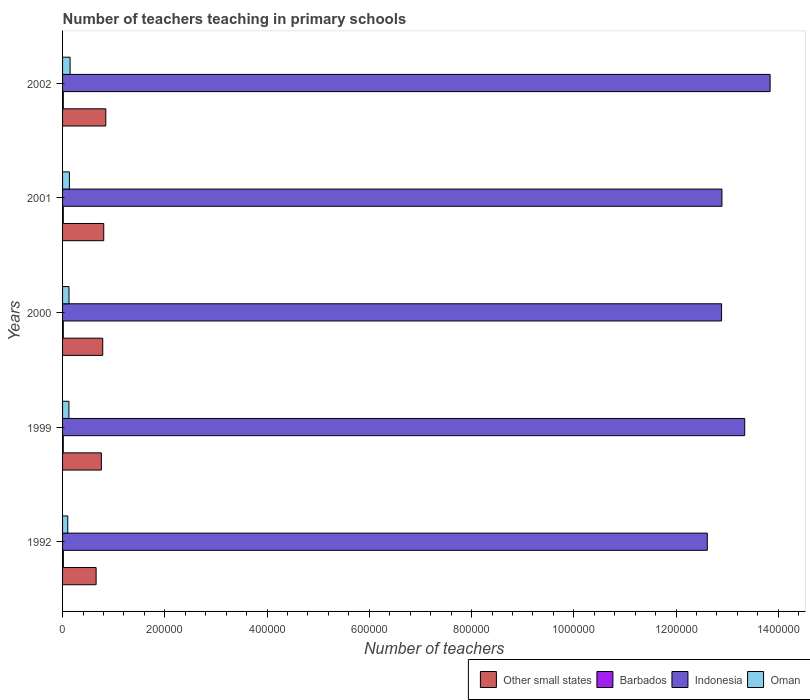How many different coloured bars are there?
Provide a succinct answer. 4. How many groups of bars are there?
Keep it short and to the point. 5. How many bars are there on the 1st tick from the bottom?
Offer a very short reply. 4. What is the label of the 1st group of bars from the top?
Give a very brief answer. 2002. What is the number of teachers teaching in primary schools in Barbados in 1992?
Offer a very short reply. 1553. Across all years, what is the maximum number of teachers teaching in primary schools in Barbados?
Provide a succinct answer. 1553. Across all years, what is the minimum number of teachers teaching in primary schools in Other small states?
Provide a short and direct response. 6.56e+04. In which year was the number of teachers teaching in primary schools in Oman minimum?
Ensure brevity in your answer.  1992. What is the total number of teachers teaching in primary schools in Oman in the graph?
Provide a short and direct response. 6.33e+04. What is the difference between the number of teachers teaching in primary schools in Other small states in 1992 and that in 2002?
Your response must be concise. -1.89e+04. What is the difference between the number of teachers teaching in primary schools in Barbados in 2001 and the number of teachers teaching in primary schools in Other small states in 1999?
Provide a succinct answer. -7.45e+04. What is the average number of teachers teaching in primary schools in Barbados per year?
Offer a terse response. 1446.8. In the year 1992, what is the difference between the number of teachers teaching in primary schools in Oman and number of teachers teaching in primary schools in Barbados?
Offer a terse response. 8631. What is the ratio of the number of teachers teaching in primary schools in Other small states in 1999 to that in 2000?
Ensure brevity in your answer.  0.97. Is the number of teachers teaching in primary schools in Other small states in 1999 less than that in 2001?
Provide a succinct answer. Yes. Is the difference between the number of teachers teaching in primary schools in Oman in 2001 and 2002 greater than the difference between the number of teachers teaching in primary schools in Barbados in 2001 and 2002?
Give a very brief answer. No. What is the difference between the highest and the second highest number of teachers teaching in primary schools in Other small states?
Offer a very short reply. 3984.84. What is the difference between the highest and the lowest number of teachers teaching in primary schools in Barbados?
Your answer should be compact. 160. Is it the case that in every year, the sum of the number of teachers teaching in primary schools in Other small states and number of teachers teaching in primary schools in Oman is greater than the sum of number of teachers teaching in primary schools in Indonesia and number of teachers teaching in primary schools in Barbados?
Your response must be concise. Yes. What does the 3rd bar from the top in 2002 represents?
Make the answer very short. Barbados. What does the 1st bar from the bottom in 1999 represents?
Your answer should be very brief. Other small states. Are all the bars in the graph horizontal?
Give a very brief answer. Yes. What is the difference between two consecutive major ticks on the X-axis?
Your response must be concise. 2.00e+05. Are the values on the major ticks of X-axis written in scientific E-notation?
Your answer should be very brief. No. Does the graph contain grids?
Make the answer very short. No. Where does the legend appear in the graph?
Offer a very short reply. Bottom right. How many legend labels are there?
Offer a very short reply. 4. How are the legend labels stacked?
Give a very brief answer. Horizontal. What is the title of the graph?
Provide a short and direct response. Number of teachers teaching in primary schools. Does "Pacific island small states" appear as one of the legend labels in the graph?
Make the answer very short. No. What is the label or title of the X-axis?
Your answer should be compact. Number of teachers. What is the Number of teachers in Other small states in 1992?
Ensure brevity in your answer.  6.56e+04. What is the Number of teachers in Barbados in 1992?
Ensure brevity in your answer.  1553. What is the Number of teachers in Indonesia in 1992?
Ensure brevity in your answer.  1.26e+06. What is the Number of teachers of Oman in 1992?
Make the answer very short. 1.02e+04. What is the Number of teachers in Other small states in 1999?
Offer a very short reply. 7.59e+04. What is the Number of teachers in Barbados in 1999?
Offer a terse response. 1395. What is the Number of teachers of Indonesia in 1999?
Make the answer very short. 1.33e+06. What is the Number of teachers of Oman in 1999?
Provide a short and direct response. 1.24e+04. What is the Number of teachers in Other small states in 2000?
Your answer should be compact. 7.86e+04. What is the Number of teachers of Barbados in 2000?
Offer a terse response. 1393. What is the Number of teachers in Indonesia in 2000?
Provide a short and direct response. 1.29e+06. What is the Number of teachers in Oman in 2000?
Keep it short and to the point. 1.26e+04. What is the Number of teachers in Other small states in 2001?
Offer a very short reply. 8.06e+04. What is the Number of teachers of Barbados in 2001?
Provide a short and direct response. 1422. What is the Number of teachers of Indonesia in 2001?
Offer a terse response. 1.29e+06. What is the Number of teachers in Oman in 2001?
Provide a succinct answer. 1.34e+04. What is the Number of teachers of Other small states in 2002?
Give a very brief answer. 8.45e+04. What is the Number of teachers of Barbados in 2002?
Provide a short and direct response. 1471. What is the Number of teachers of Indonesia in 2002?
Your response must be concise. 1.38e+06. What is the Number of teachers of Oman in 2002?
Your answer should be compact. 1.47e+04. Across all years, what is the maximum Number of teachers of Other small states?
Offer a very short reply. 8.45e+04. Across all years, what is the maximum Number of teachers in Barbados?
Keep it short and to the point. 1553. Across all years, what is the maximum Number of teachers of Indonesia?
Offer a terse response. 1.38e+06. Across all years, what is the maximum Number of teachers of Oman?
Provide a succinct answer. 1.47e+04. Across all years, what is the minimum Number of teachers of Other small states?
Offer a very short reply. 6.56e+04. Across all years, what is the minimum Number of teachers of Barbados?
Give a very brief answer. 1393. Across all years, what is the minimum Number of teachers in Indonesia?
Your response must be concise. 1.26e+06. Across all years, what is the minimum Number of teachers in Oman?
Offer a very short reply. 1.02e+04. What is the total Number of teachers of Other small states in the graph?
Your response must be concise. 3.85e+05. What is the total Number of teachers in Barbados in the graph?
Your answer should be compact. 7234. What is the total Number of teachers of Indonesia in the graph?
Offer a terse response. 6.56e+06. What is the total Number of teachers of Oman in the graph?
Give a very brief answer. 6.33e+04. What is the difference between the Number of teachers of Other small states in 1992 and that in 1999?
Make the answer very short. -1.03e+04. What is the difference between the Number of teachers of Barbados in 1992 and that in 1999?
Ensure brevity in your answer.  158. What is the difference between the Number of teachers in Indonesia in 1992 and that in 1999?
Provide a short and direct response. -7.31e+04. What is the difference between the Number of teachers of Oman in 1992 and that in 1999?
Your answer should be very brief. -2237. What is the difference between the Number of teachers in Other small states in 1992 and that in 2000?
Your answer should be very brief. -1.30e+04. What is the difference between the Number of teachers of Barbados in 1992 and that in 2000?
Ensure brevity in your answer.  160. What is the difference between the Number of teachers of Indonesia in 1992 and that in 2000?
Make the answer very short. -2.79e+04. What is the difference between the Number of teachers of Oman in 1992 and that in 2000?
Your answer should be very brief. -2414. What is the difference between the Number of teachers of Other small states in 1992 and that in 2001?
Your response must be concise. -1.50e+04. What is the difference between the Number of teachers of Barbados in 1992 and that in 2001?
Your answer should be very brief. 131. What is the difference between the Number of teachers of Indonesia in 1992 and that in 2001?
Provide a short and direct response. -2.86e+04. What is the difference between the Number of teachers in Oman in 1992 and that in 2001?
Provide a succinct answer. -3210. What is the difference between the Number of teachers in Other small states in 1992 and that in 2002?
Provide a succinct answer. -1.89e+04. What is the difference between the Number of teachers of Indonesia in 1992 and that in 2002?
Ensure brevity in your answer.  -1.23e+05. What is the difference between the Number of teachers in Oman in 1992 and that in 2002?
Offer a very short reply. -4544. What is the difference between the Number of teachers in Other small states in 1999 and that in 2000?
Ensure brevity in your answer.  -2707.27. What is the difference between the Number of teachers of Barbados in 1999 and that in 2000?
Offer a very short reply. 2. What is the difference between the Number of teachers of Indonesia in 1999 and that in 2000?
Provide a short and direct response. 4.52e+04. What is the difference between the Number of teachers of Oman in 1999 and that in 2000?
Keep it short and to the point. -177. What is the difference between the Number of teachers of Other small states in 1999 and that in 2001?
Offer a terse response. -4683.12. What is the difference between the Number of teachers of Barbados in 1999 and that in 2001?
Ensure brevity in your answer.  -27. What is the difference between the Number of teachers of Indonesia in 1999 and that in 2001?
Give a very brief answer. 4.45e+04. What is the difference between the Number of teachers of Oman in 1999 and that in 2001?
Your answer should be compact. -973. What is the difference between the Number of teachers of Other small states in 1999 and that in 2002?
Your response must be concise. -8667.97. What is the difference between the Number of teachers in Barbados in 1999 and that in 2002?
Provide a short and direct response. -76. What is the difference between the Number of teachers in Indonesia in 1999 and that in 2002?
Keep it short and to the point. -4.97e+04. What is the difference between the Number of teachers of Oman in 1999 and that in 2002?
Give a very brief answer. -2307. What is the difference between the Number of teachers of Other small states in 2000 and that in 2001?
Your response must be concise. -1975.86. What is the difference between the Number of teachers in Indonesia in 2000 and that in 2001?
Keep it short and to the point. -755. What is the difference between the Number of teachers in Oman in 2000 and that in 2001?
Your answer should be very brief. -796. What is the difference between the Number of teachers of Other small states in 2000 and that in 2002?
Your response must be concise. -5960.7. What is the difference between the Number of teachers of Barbados in 2000 and that in 2002?
Make the answer very short. -78. What is the difference between the Number of teachers of Indonesia in 2000 and that in 2002?
Provide a short and direct response. -9.49e+04. What is the difference between the Number of teachers of Oman in 2000 and that in 2002?
Offer a terse response. -2130. What is the difference between the Number of teachers in Other small states in 2001 and that in 2002?
Offer a very short reply. -3984.84. What is the difference between the Number of teachers in Barbados in 2001 and that in 2002?
Your response must be concise. -49. What is the difference between the Number of teachers in Indonesia in 2001 and that in 2002?
Your answer should be compact. -9.42e+04. What is the difference between the Number of teachers in Oman in 2001 and that in 2002?
Ensure brevity in your answer.  -1334. What is the difference between the Number of teachers of Other small states in 1992 and the Number of teachers of Barbados in 1999?
Your response must be concise. 6.42e+04. What is the difference between the Number of teachers of Other small states in 1992 and the Number of teachers of Indonesia in 1999?
Keep it short and to the point. -1.27e+06. What is the difference between the Number of teachers in Other small states in 1992 and the Number of teachers in Oman in 1999?
Provide a short and direct response. 5.32e+04. What is the difference between the Number of teachers of Barbados in 1992 and the Number of teachers of Indonesia in 1999?
Keep it short and to the point. -1.33e+06. What is the difference between the Number of teachers in Barbados in 1992 and the Number of teachers in Oman in 1999?
Keep it short and to the point. -1.09e+04. What is the difference between the Number of teachers of Indonesia in 1992 and the Number of teachers of Oman in 1999?
Make the answer very short. 1.25e+06. What is the difference between the Number of teachers of Other small states in 1992 and the Number of teachers of Barbados in 2000?
Offer a very short reply. 6.42e+04. What is the difference between the Number of teachers of Other small states in 1992 and the Number of teachers of Indonesia in 2000?
Offer a terse response. -1.22e+06. What is the difference between the Number of teachers in Other small states in 1992 and the Number of teachers in Oman in 2000?
Keep it short and to the point. 5.30e+04. What is the difference between the Number of teachers of Barbados in 1992 and the Number of teachers of Indonesia in 2000?
Keep it short and to the point. -1.29e+06. What is the difference between the Number of teachers of Barbados in 1992 and the Number of teachers of Oman in 2000?
Keep it short and to the point. -1.10e+04. What is the difference between the Number of teachers in Indonesia in 1992 and the Number of teachers in Oman in 2000?
Make the answer very short. 1.25e+06. What is the difference between the Number of teachers in Other small states in 1992 and the Number of teachers in Barbados in 2001?
Your answer should be very brief. 6.42e+04. What is the difference between the Number of teachers in Other small states in 1992 and the Number of teachers in Indonesia in 2001?
Offer a very short reply. -1.22e+06. What is the difference between the Number of teachers of Other small states in 1992 and the Number of teachers of Oman in 2001?
Your answer should be very brief. 5.22e+04. What is the difference between the Number of teachers of Barbados in 1992 and the Number of teachers of Indonesia in 2001?
Keep it short and to the point. -1.29e+06. What is the difference between the Number of teachers of Barbados in 1992 and the Number of teachers of Oman in 2001?
Offer a very short reply. -1.18e+04. What is the difference between the Number of teachers of Indonesia in 1992 and the Number of teachers of Oman in 2001?
Your answer should be compact. 1.25e+06. What is the difference between the Number of teachers in Other small states in 1992 and the Number of teachers in Barbados in 2002?
Your answer should be compact. 6.41e+04. What is the difference between the Number of teachers in Other small states in 1992 and the Number of teachers in Indonesia in 2002?
Give a very brief answer. -1.32e+06. What is the difference between the Number of teachers in Other small states in 1992 and the Number of teachers in Oman in 2002?
Your answer should be very brief. 5.09e+04. What is the difference between the Number of teachers in Barbados in 1992 and the Number of teachers in Indonesia in 2002?
Your response must be concise. -1.38e+06. What is the difference between the Number of teachers in Barbados in 1992 and the Number of teachers in Oman in 2002?
Ensure brevity in your answer.  -1.32e+04. What is the difference between the Number of teachers of Indonesia in 1992 and the Number of teachers of Oman in 2002?
Make the answer very short. 1.25e+06. What is the difference between the Number of teachers in Other small states in 1999 and the Number of teachers in Barbados in 2000?
Provide a succinct answer. 7.45e+04. What is the difference between the Number of teachers of Other small states in 1999 and the Number of teachers of Indonesia in 2000?
Make the answer very short. -1.21e+06. What is the difference between the Number of teachers in Other small states in 1999 and the Number of teachers in Oman in 2000?
Provide a succinct answer. 6.33e+04. What is the difference between the Number of teachers in Barbados in 1999 and the Number of teachers in Indonesia in 2000?
Ensure brevity in your answer.  -1.29e+06. What is the difference between the Number of teachers of Barbados in 1999 and the Number of teachers of Oman in 2000?
Give a very brief answer. -1.12e+04. What is the difference between the Number of teachers of Indonesia in 1999 and the Number of teachers of Oman in 2000?
Offer a very short reply. 1.32e+06. What is the difference between the Number of teachers in Other small states in 1999 and the Number of teachers in Barbados in 2001?
Your answer should be very brief. 7.45e+04. What is the difference between the Number of teachers in Other small states in 1999 and the Number of teachers in Indonesia in 2001?
Give a very brief answer. -1.21e+06. What is the difference between the Number of teachers of Other small states in 1999 and the Number of teachers of Oman in 2001?
Give a very brief answer. 6.25e+04. What is the difference between the Number of teachers in Barbados in 1999 and the Number of teachers in Indonesia in 2001?
Offer a terse response. -1.29e+06. What is the difference between the Number of teachers of Barbados in 1999 and the Number of teachers of Oman in 2001?
Your response must be concise. -1.20e+04. What is the difference between the Number of teachers of Indonesia in 1999 and the Number of teachers of Oman in 2001?
Your answer should be compact. 1.32e+06. What is the difference between the Number of teachers in Other small states in 1999 and the Number of teachers in Barbados in 2002?
Provide a short and direct response. 7.44e+04. What is the difference between the Number of teachers of Other small states in 1999 and the Number of teachers of Indonesia in 2002?
Give a very brief answer. -1.31e+06. What is the difference between the Number of teachers of Other small states in 1999 and the Number of teachers of Oman in 2002?
Your answer should be very brief. 6.11e+04. What is the difference between the Number of teachers in Barbados in 1999 and the Number of teachers in Indonesia in 2002?
Your answer should be very brief. -1.38e+06. What is the difference between the Number of teachers of Barbados in 1999 and the Number of teachers of Oman in 2002?
Provide a succinct answer. -1.33e+04. What is the difference between the Number of teachers of Indonesia in 1999 and the Number of teachers of Oman in 2002?
Make the answer very short. 1.32e+06. What is the difference between the Number of teachers of Other small states in 2000 and the Number of teachers of Barbados in 2001?
Your answer should be very brief. 7.72e+04. What is the difference between the Number of teachers in Other small states in 2000 and the Number of teachers in Indonesia in 2001?
Make the answer very short. -1.21e+06. What is the difference between the Number of teachers of Other small states in 2000 and the Number of teachers of Oman in 2001?
Give a very brief answer. 6.52e+04. What is the difference between the Number of teachers in Barbados in 2000 and the Number of teachers in Indonesia in 2001?
Your response must be concise. -1.29e+06. What is the difference between the Number of teachers in Barbados in 2000 and the Number of teachers in Oman in 2001?
Make the answer very short. -1.20e+04. What is the difference between the Number of teachers of Indonesia in 2000 and the Number of teachers of Oman in 2001?
Your answer should be compact. 1.28e+06. What is the difference between the Number of teachers in Other small states in 2000 and the Number of teachers in Barbados in 2002?
Offer a terse response. 7.71e+04. What is the difference between the Number of teachers in Other small states in 2000 and the Number of teachers in Indonesia in 2002?
Offer a terse response. -1.31e+06. What is the difference between the Number of teachers in Other small states in 2000 and the Number of teachers in Oman in 2002?
Keep it short and to the point. 6.39e+04. What is the difference between the Number of teachers of Barbados in 2000 and the Number of teachers of Indonesia in 2002?
Ensure brevity in your answer.  -1.38e+06. What is the difference between the Number of teachers in Barbados in 2000 and the Number of teachers in Oman in 2002?
Provide a succinct answer. -1.33e+04. What is the difference between the Number of teachers in Indonesia in 2000 and the Number of teachers in Oman in 2002?
Provide a succinct answer. 1.27e+06. What is the difference between the Number of teachers of Other small states in 2001 and the Number of teachers of Barbados in 2002?
Your response must be concise. 7.91e+04. What is the difference between the Number of teachers in Other small states in 2001 and the Number of teachers in Indonesia in 2002?
Your answer should be compact. -1.30e+06. What is the difference between the Number of teachers in Other small states in 2001 and the Number of teachers in Oman in 2002?
Offer a very short reply. 6.58e+04. What is the difference between the Number of teachers of Barbados in 2001 and the Number of teachers of Indonesia in 2002?
Your response must be concise. -1.38e+06. What is the difference between the Number of teachers in Barbados in 2001 and the Number of teachers in Oman in 2002?
Your answer should be compact. -1.33e+04. What is the difference between the Number of teachers of Indonesia in 2001 and the Number of teachers of Oman in 2002?
Provide a short and direct response. 1.27e+06. What is the average Number of teachers of Other small states per year?
Make the answer very short. 7.70e+04. What is the average Number of teachers in Barbados per year?
Provide a short and direct response. 1446.8. What is the average Number of teachers in Indonesia per year?
Give a very brief answer. 1.31e+06. What is the average Number of teachers of Oman per year?
Keep it short and to the point. 1.27e+04. In the year 1992, what is the difference between the Number of teachers of Other small states and Number of teachers of Barbados?
Provide a succinct answer. 6.40e+04. In the year 1992, what is the difference between the Number of teachers of Other small states and Number of teachers of Indonesia?
Your response must be concise. -1.20e+06. In the year 1992, what is the difference between the Number of teachers in Other small states and Number of teachers in Oman?
Make the answer very short. 5.54e+04. In the year 1992, what is the difference between the Number of teachers of Barbados and Number of teachers of Indonesia?
Offer a terse response. -1.26e+06. In the year 1992, what is the difference between the Number of teachers of Barbados and Number of teachers of Oman?
Make the answer very short. -8631. In the year 1992, what is the difference between the Number of teachers of Indonesia and Number of teachers of Oman?
Give a very brief answer. 1.25e+06. In the year 1999, what is the difference between the Number of teachers in Other small states and Number of teachers in Barbados?
Offer a very short reply. 7.45e+04. In the year 1999, what is the difference between the Number of teachers in Other small states and Number of teachers in Indonesia?
Your response must be concise. -1.26e+06. In the year 1999, what is the difference between the Number of teachers in Other small states and Number of teachers in Oman?
Offer a terse response. 6.35e+04. In the year 1999, what is the difference between the Number of teachers in Barbados and Number of teachers in Indonesia?
Give a very brief answer. -1.33e+06. In the year 1999, what is the difference between the Number of teachers in Barbados and Number of teachers in Oman?
Your answer should be very brief. -1.10e+04. In the year 1999, what is the difference between the Number of teachers of Indonesia and Number of teachers of Oman?
Offer a terse response. 1.32e+06. In the year 2000, what is the difference between the Number of teachers of Other small states and Number of teachers of Barbados?
Your answer should be very brief. 7.72e+04. In the year 2000, what is the difference between the Number of teachers in Other small states and Number of teachers in Indonesia?
Make the answer very short. -1.21e+06. In the year 2000, what is the difference between the Number of teachers in Other small states and Number of teachers in Oman?
Your answer should be very brief. 6.60e+04. In the year 2000, what is the difference between the Number of teachers of Barbados and Number of teachers of Indonesia?
Your answer should be compact. -1.29e+06. In the year 2000, what is the difference between the Number of teachers in Barbados and Number of teachers in Oman?
Offer a very short reply. -1.12e+04. In the year 2000, what is the difference between the Number of teachers of Indonesia and Number of teachers of Oman?
Offer a terse response. 1.28e+06. In the year 2001, what is the difference between the Number of teachers in Other small states and Number of teachers in Barbados?
Offer a terse response. 7.91e+04. In the year 2001, what is the difference between the Number of teachers of Other small states and Number of teachers of Indonesia?
Keep it short and to the point. -1.21e+06. In the year 2001, what is the difference between the Number of teachers of Other small states and Number of teachers of Oman?
Your response must be concise. 6.72e+04. In the year 2001, what is the difference between the Number of teachers in Barbados and Number of teachers in Indonesia?
Your response must be concise. -1.29e+06. In the year 2001, what is the difference between the Number of teachers of Barbados and Number of teachers of Oman?
Ensure brevity in your answer.  -1.20e+04. In the year 2001, what is the difference between the Number of teachers of Indonesia and Number of teachers of Oman?
Your answer should be very brief. 1.28e+06. In the year 2002, what is the difference between the Number of teachers in Other small states and Number of teachers in Barbados?
Offer a very short reply. 8.31e+04. In the year 2002, what is the difference between the Number of teachers in Other small states and Number of teachers in Indonesia?
Ensure brevity in your answer.  -1.30e+06. In the year 2002, what is the difference between the Number of teachers in Other small states and Number of teachers in Oman?
Your response must be concise. 6.98e+04. In the year 2002, what is the difference between the Number of teachers of Barbados and Number of teachers of Indonesia?
Make the answer very short. -1.38e+06. In the year 2002, what is the difference between the Number of teachers of Barbados and Number of teachers of Oman?
Provide a short and direct response. -1.33e+04. In the year 2002, what is the difference between the Number of teachers in Indonesia and Number of teachers in Oman?
Give a very brief answer. 1.37e+06. What is the ratio of the Number of teachers of Other small states in 1992 to that in 1999?
Provide a succinct answer. 0.86. What is the ratio of the Number of teachers in Barbados in 1992 to that in 1999?
Offer a terse response. 1.11. What is the ratio of the Number of teachers in Indonesia in 1992 to that in 1999?
Your answer should be compact. 0.95. What is the ratio of the Number of teachers of Oman in 1992 to that in 1999?
Offer a terse response. 0.82. What is the ratio of the Number of teachers in Other small states in 1992 to that in 2000?
Provide a succinct answer. 0.83. What is the ratio of the Number of teachers in Barbados in 1992 to that in 2000?
Offer a very short reply. 1.11. What is the ratio of the Number of teachers in Indonesia in 1992 to that in 2000?
Provide a succinct answer. 0.98. What is the ratio of the Number of teachers of Oman in 1992 to that in 2000?
Make the answer very short. 0.81. What is the ratio of the Number of teachers in Other small states in 1992 to that in 2001?
Offer a very short reply. 0.81. What is the ratio of the Number of teachers of Barbados in 1992 to that in 2001?
Keep it short and to the point. 1.09. What is the ratio of the Number of teachers of Indonesia in 1992 to that in 2001?
Your response must be concise. 0.98. What is the ratio of the Number of teachers in Oman in 1992 to that in 2001?
Give a very brief answer. 0.76. What is the ratio of the Number of teachers of Other small states in 1992 to that in 2002?
Your response must be concise. 0.78. What is the ratio of the Number of teachers in Barbados in 1992 to that in 2002?
Your response must be concise. 1.06. What is the ratio of the Number of teachers of Indonesia in 1992 to that in 2002?
Make the answer very short. 0.91. What is the ratio of the Number of teachers of Oman in 1992 to that in 2002?
Make the answer very short. 0.69. What is the ratio of the Number of teachers in Other small states in 1999 to that in 2000?
Provide a short and direct response. 0.97. What is the ratio of the Number of teachers in Indonesia in 1999 to that in 2000?
Your answer should be very brief. 1.04. What is the ratio of the Number of teachers of Other small states in 1999 to that in 2001?
Your answer should be compact. 0.94. What is the ratio of the Number of teachers in Indonesia in 1999 to that in 2001?
Offer a very short reply. 1.03. What is the ratio of the Number of teachers of Oman in 1999 to that in 2001?
Your response must be concise. 0.93. What is the ratio of the Number of teachers of Other small states in 1999 to that in 2002?
Your response must be concise. 0.9. What is the ratio of the Number of teachers of Barbados in 1999 to that in 2002?
Make the answer very short. 0.95. What is the ratio of the Number of teachers in Indonesia in 1999 to that in 2002?
Make the answer very short. 0.96. What is the ratio of the Number of teachers of Oman in 1999 to that in 2002?
Provide a succinct answer. 0.84. What is the ratio of the Number of teachers in Other small states in 2000 to that in 2001?
Your answer should be very brief. 0.98. What is the ratio of the Number of teachers of Barbados in 2000 to that in 2001?
Give a very brief answer. 0.98. What is the ratio of the Number of teachers of Oman in 2000 to that in 2001?
Your answer should be very brief. 0.94. What is the ratio of the Number of teachers of Other small states in 2000 to that in 2002?
Provide a succinct answer. 0.93. What is the ratio of the Number of teachers in Barbados in 2000 to that in 2002?
Offer a terse response. 0.95. What is the ratio of the Number of teachers of Indonesia in 2000 to that in 2002?
Provide a succinct answer. 0.93. What is the ratio of the Number of teachers of Oman in 2000 to that in 2002?
Make the answer very short. 0.86. What is the ratio of the Number of teachers in Other small states in 2001 to that in 2002?
Provide a succinct answer. 0.95. What is the ratio of the Number of teachers in Barbados in 2001 to that in 2002?
Offer a very short reply. 0.97. What is the ratio of the Number of teachers of Indonesia in 2001 to that in 2002?
Provide a short and direct response. 0.93. What is the ratio of the Number of teachers in Oman in 2001 to that in 2002?
Your answer should be compact. 0.91. What is the difference between the highest and the second highest Number of teachers in Other small states?
Make the answer very short. 3984.84. What is the difference between the highest and the second highest Number of teachers in Barbados?
Offer a terse response. 82. What is the difference between the highest and the second highest Number of teachers in Indonesia?
Ensure brevity in your answer.  4.97e+04. What is the difference between the highest and the second highest Number of teachers in Oman?
Ensure brevity in your answer.  1334. What is the difference between the highest and the lowest Number of teachers in Other small states?
Your answer should be compact. 1.89e+04. What is the difference between the highest and the lowest Number of teachers of Barbados?
Ensure brevity in your answer.  160. What is the difference between the highest and the lowest Number of teachers of Indonesia?
Provide a short and direct response. 1.23e+05. What is the difference between the highest and the lowest Number of teachers of Oman?
Offer a terse response. 4544. 